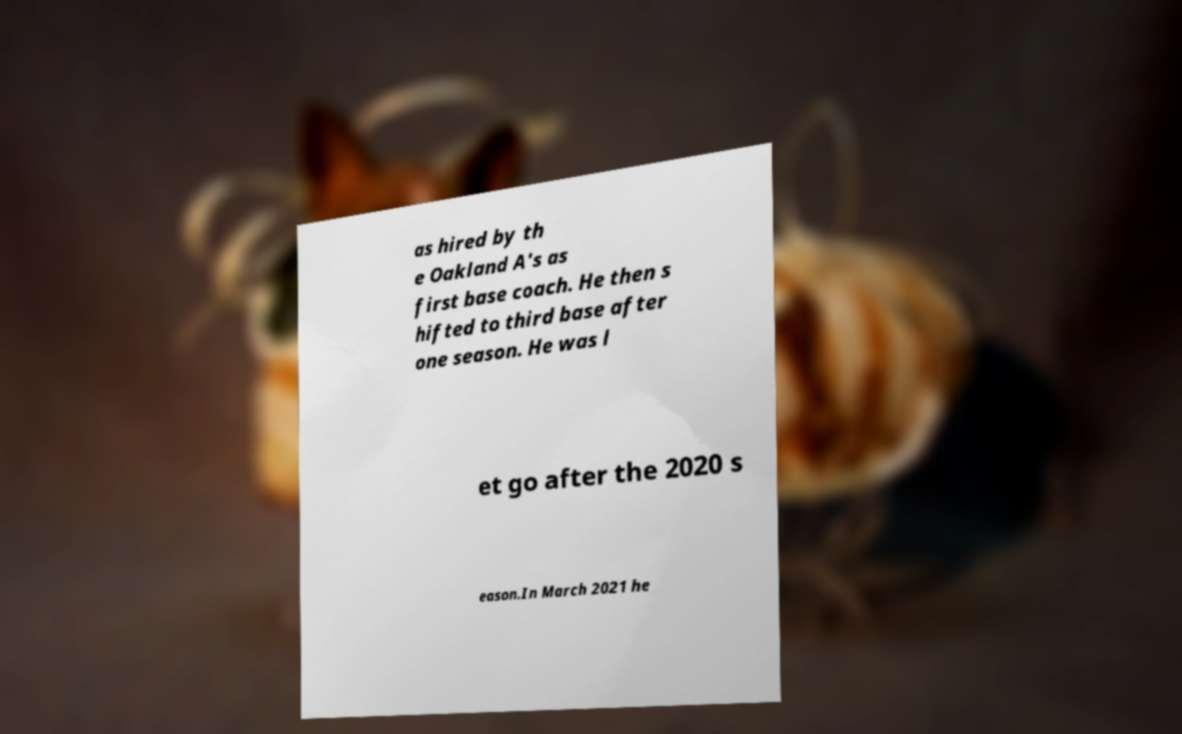For documentation purposes, I need the text within this image transcribed. Could you provide that? as hired by th e Oakland A's as first base coach. He then s hifted to third base after one season. He was l et go after the 2020 s eason.In March 2021 he 